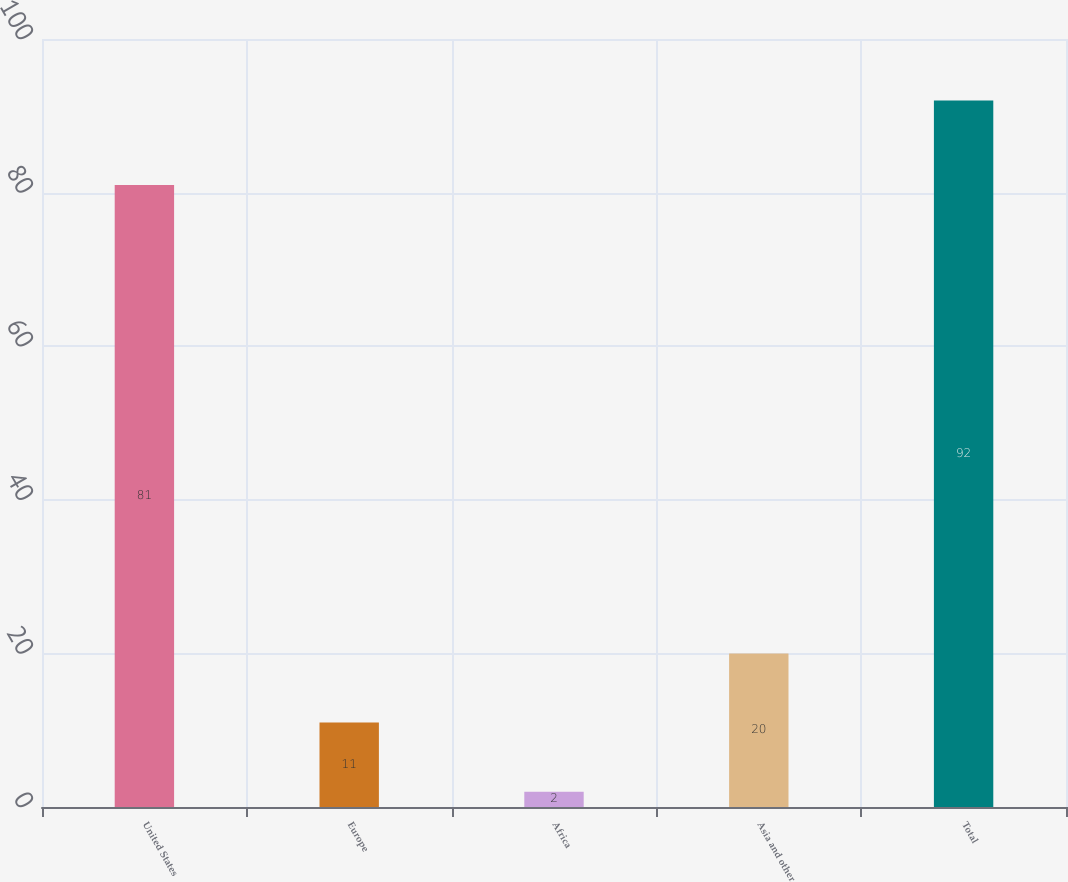<chart> <loc_0><loc_0><loc_500><loc_500><bar_chart><fcel>United States<fcel>Europe<fcel>Africa<fcel>Asia and other<fcel>Total<nl><fcel>81<fcel>11<fcel>2<fcel>20<fcel>92<nl></chart> 